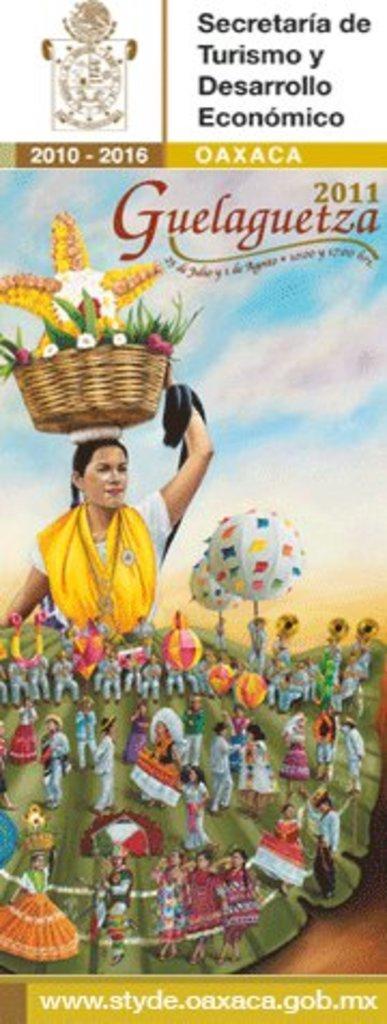Please provide a concise description of this image. In this image we can see a poster with some images and text on it. 